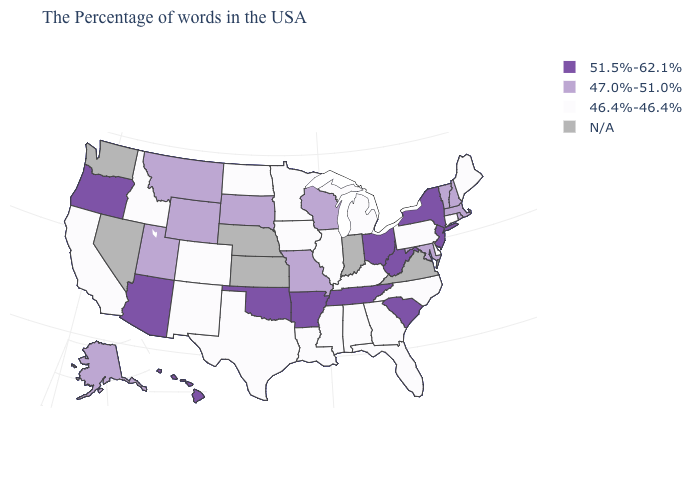What is the value of Oregon?
Keep it brief. 51.5%-62.1%. What is the value of Massachusetts?
Concise answer only. 47.0%-51.0%. Which states have the lowest value in the USA?
Write a very short answer. Maine, Connecticut, Delaware, Pennsylvania, North Carolina, Florida, Georgia, Michigan, Kentucky, Alabama, Illinois, Mississippi, Louisiana, Minnesota, Iowa, Texas, North Dakota, Colorado, New Mexico, Idaho, California. Which states have the lowest value in the USA?
Short answer required. Maine, Connecticut, Delaware, Pennsylvania, North Carolina, Florida, Georgia, Michigan, Kentucky, Alabama, Illinois, Mississippi, Louisiana, Minnesota, Iowa, Texas, North Dakota, Colorado, New Mexico, Idaho, California. What is the value of Hawaii?
Concise answer only. 51.5%-62.1%. Which states have the lowest value in the MidWest?
Keep it brief. Michigan, Illinois, Minnesota, Iowa, North Dakota. Does the first symbol in the legend represent the smallest category?
Concise answer only. No. What is the value of West Virginia?
Give a very brief answer. 51.5%-62.1%. Name the states that have a value in the range N/A?
Write a very short answer. Virginia, Indiana, Kansas, Nebraska, Nevada, Washington. What is the lowest value in states that border Mississippi?
Give a very brief answer. 46.4%-46.4%. What is the value of New Mexico?
Be succinct. 46.4%-46.4%. Name the states that have a value in the range 46.4%-46.4%?
Write a very short answer. Maine, Connecticut, Delaware, Pennsylvania, North Carolina, Florida, Georgia, Michigan, Kentucky, Alabama, Illinois, Mississippi, Louisiana, Minnesota, Iowa, Texas, North Dakota, Colorado, New Mexico, Idaho, California. What is the value of South Carolina?
Give a very brief answer. 51.5%-62.1%. Is the legend a continuous bar?
Be succinct. No. 